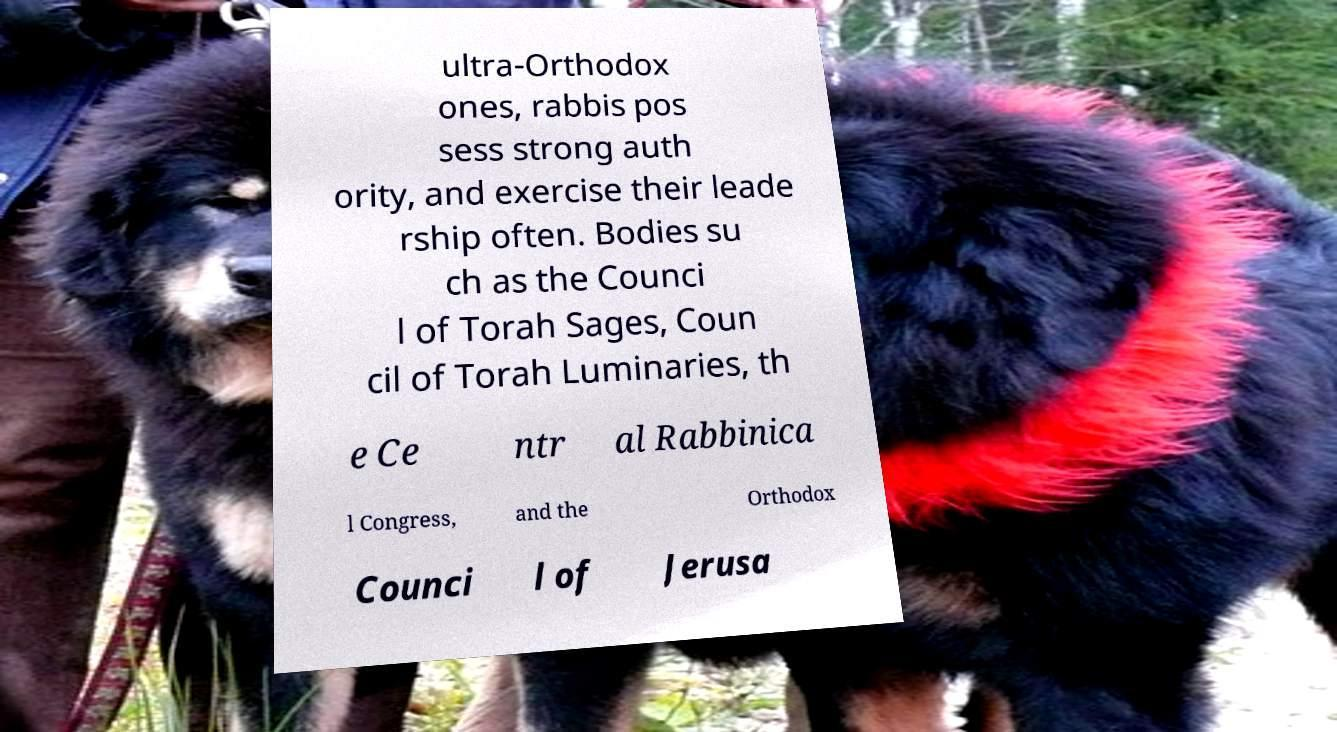Please read and relay the text visible in this image. What does it say? ultra-Orthodox ones, rabbis pos sess strong auth ority, and exercise their leade rship often. Bodies su ch as the Counci l of Torah Sages, Coun cil of Torah Luminaries, th e Ce ntr al Rabbinica l Congress, and the Orthodox Counci l of Jerusa 